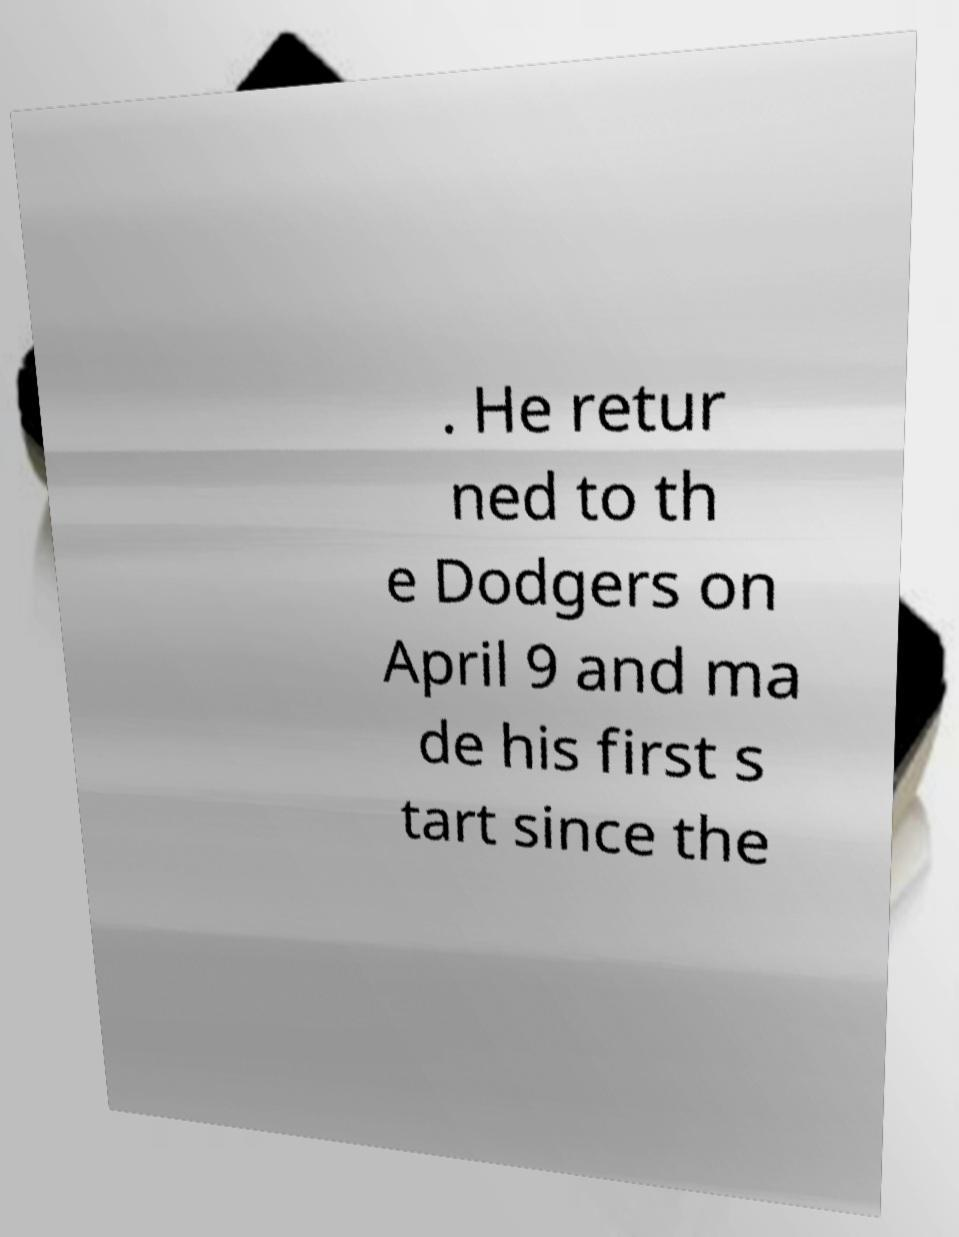Can you accurately transcribe the text from the provided image for me? . He retur ned to th e Dodgers on April 9 and ma de his first s tart since the 